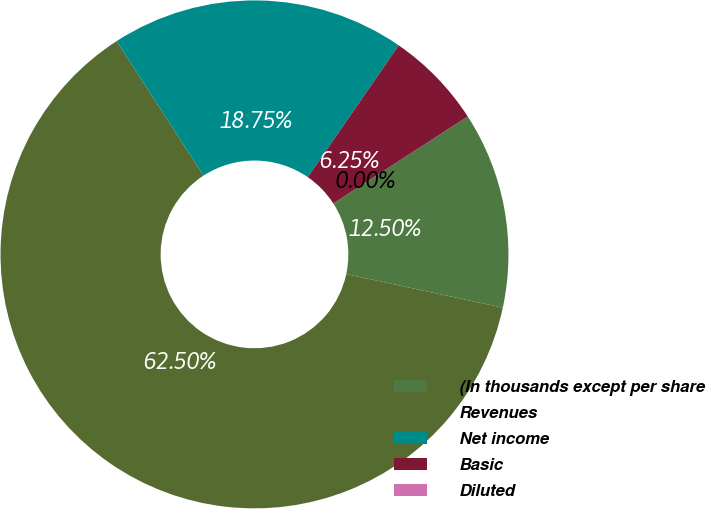Convert chart. <chart><loc_0><loc_0><loc_500><loc_500><pie_chart><fcel>(In thousands except per share<fcel>Revenues<fcel>Net income<fcel>Basic<fcel>Diluted<nl><fcel>12.5%<fcel>62.5%<fcel>18.75%<fcel>6.25%<fcel>0.0%<nl></chart> 